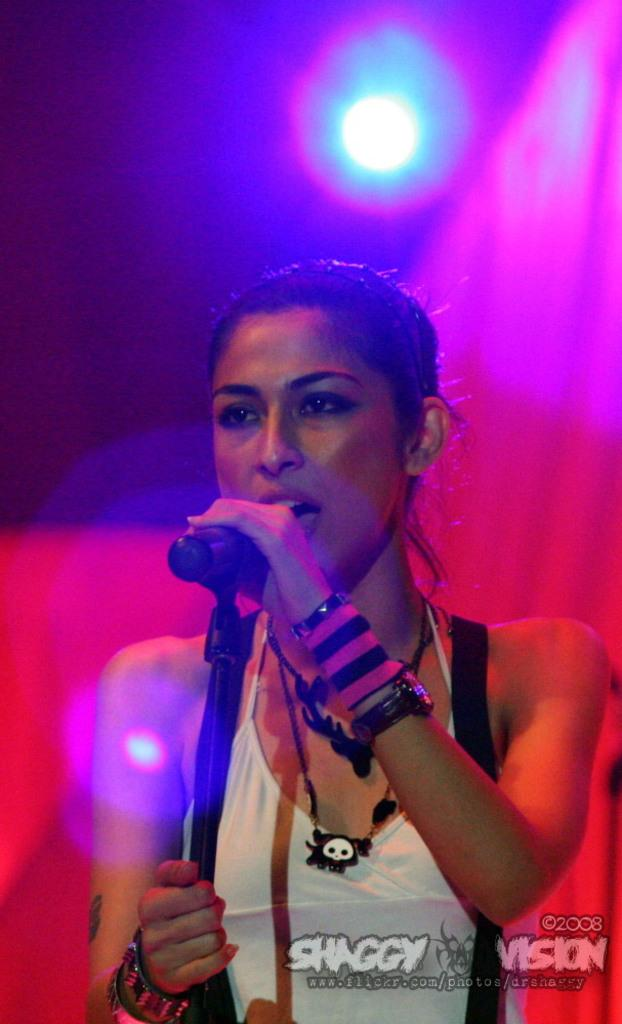What is the lady in the image wearing? The lady in the image is wearing a white dress. What is the lady doing in the image? The lady is singing in the image. What is the lady holding in her hand? The lady is holding a mic in her hand. What can be seen in the background of the image? There is a red curtain in the background of the image. What is above the red curtain in the image? There is an LED light above the red curtain in the image. What type of paint is used on the rod in the image? There is no rod or paint present in the image. 